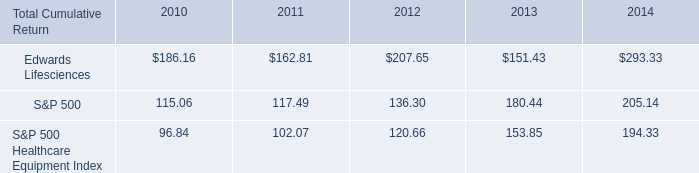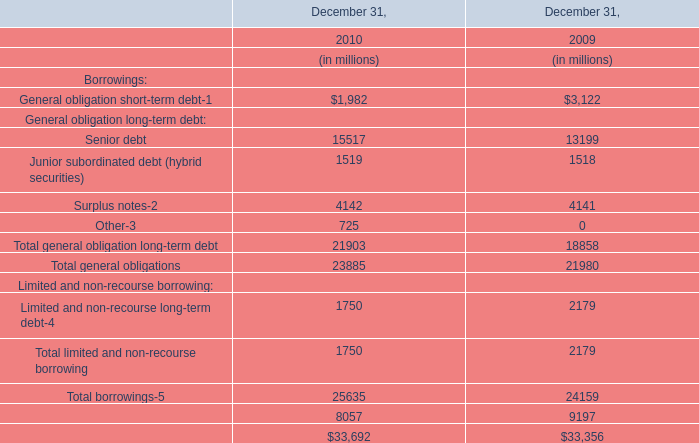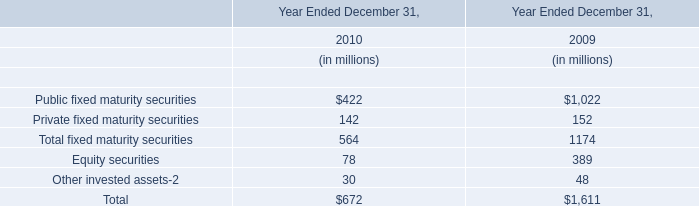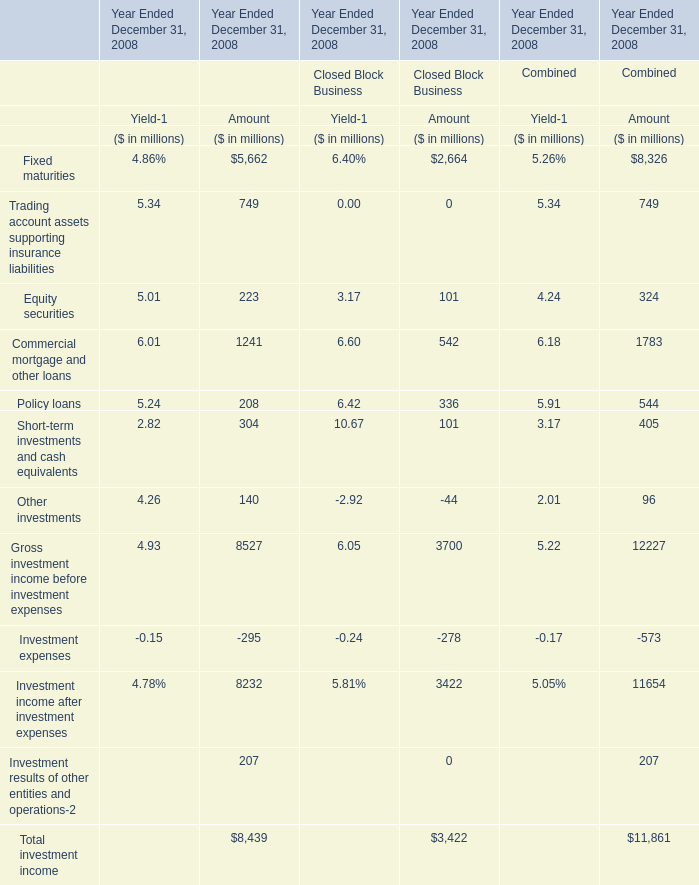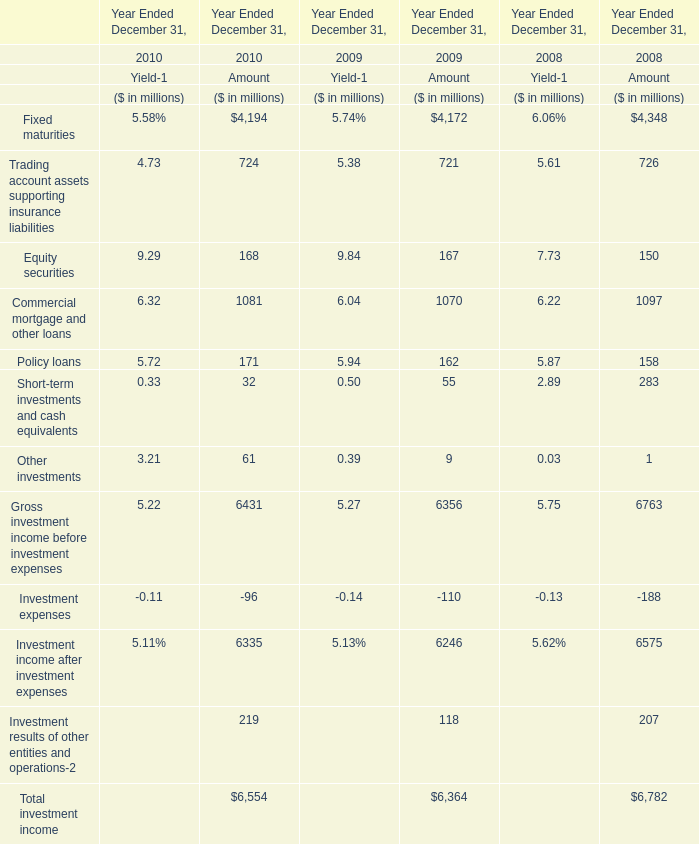What is the Amount of Other investments in 2009 Ended December 31 ? (in million) 
Answer: 9. 